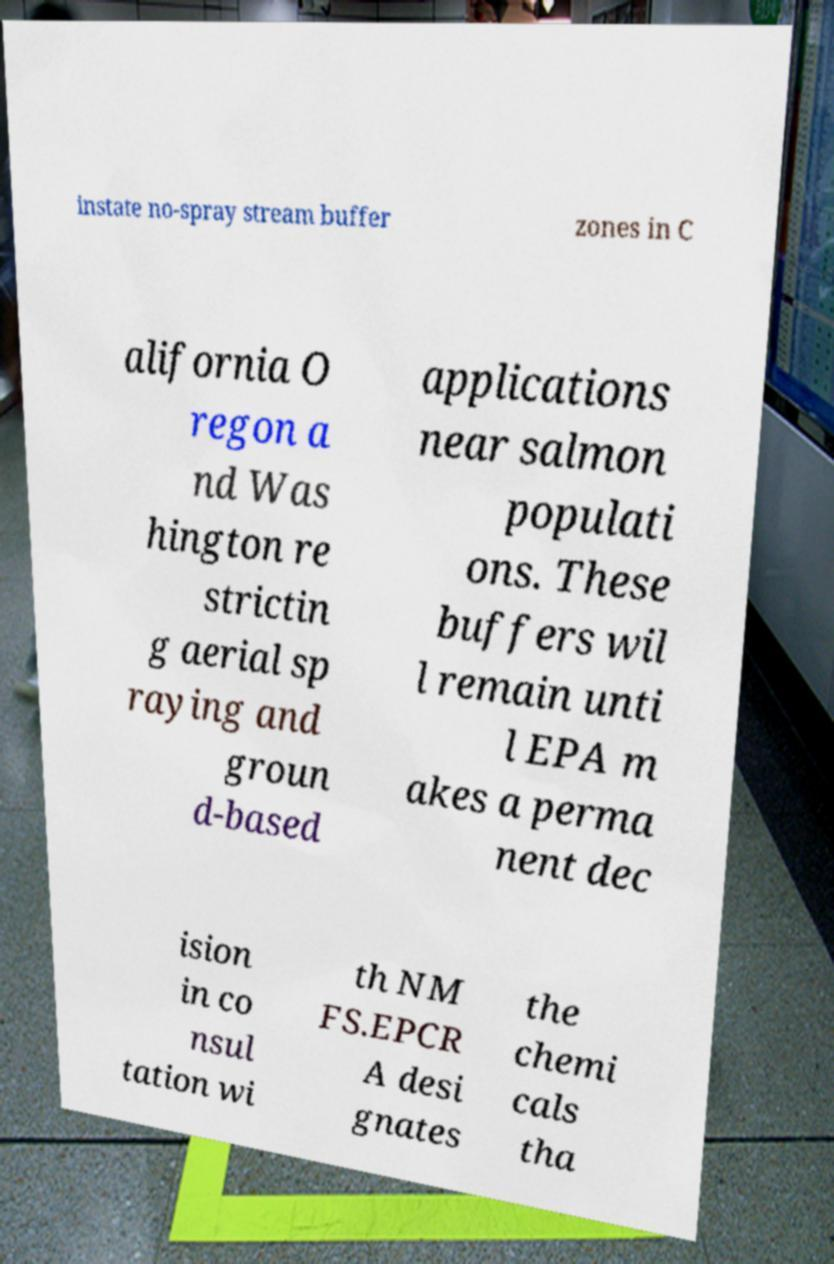Could you extract and type out the text from this image? instate no-spray stream buffer zones in C alifornia O regon a nd Was hington re strictin g aerial sp raying and groun d-based applications near salmon populati ons. These buffers wil l remain unti l EPA m akes a perma nent dec ision in co nsul tation wi th NM FS.EPCR A desi gnates the chemi cals tha 